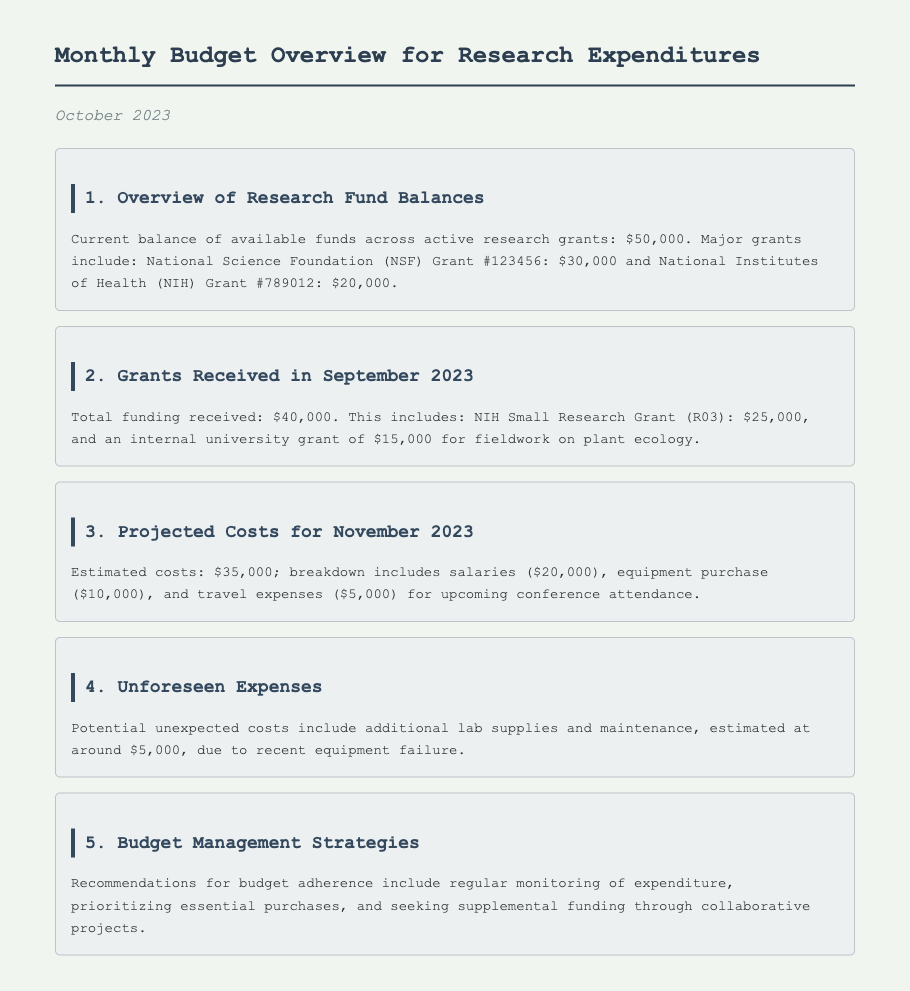What is the current balance of available funds? The current balance is stated in the document as the total of active research grants.
Answer: $50,000 What major grant is mentioned with the highest amount? The document lists two major grants, and the one with the highest amount is the NSF Grant.
Answer: NSF Grant #123456 How much total funding was received in September 2023? The total funding received is explicitly stated in the document.
Answer: $40,000 What are the estimated travel expenses for November 2023? The projected costs include a specific breakdown of expenses, where travel is mentioned.
Answer: $5,000 What unforeseen expense is mentioned? The document indicates a specific type of unforeseen expense due to equipment issues.
Answer: Lab supplies and maintenance What is the recommended strategy for budget adherence? The document lists several strategies, and one focuses on monitoring expenditures.
Answer: Regular monitoring of expenditure How much is allocated for equipment purchases in November 2023? The breakdown of projected costs for November includes specific allocations.
Answer: $10,000 What internal grant was received for plant ecology fieldwork? The document specifically names an internal grant related to the research area.
Answer: Internal university grant What potential unexpected costs are mentioned in the document? The document mentions estimated additional costs that may arise unexpectedly.
Answer: $5,000 